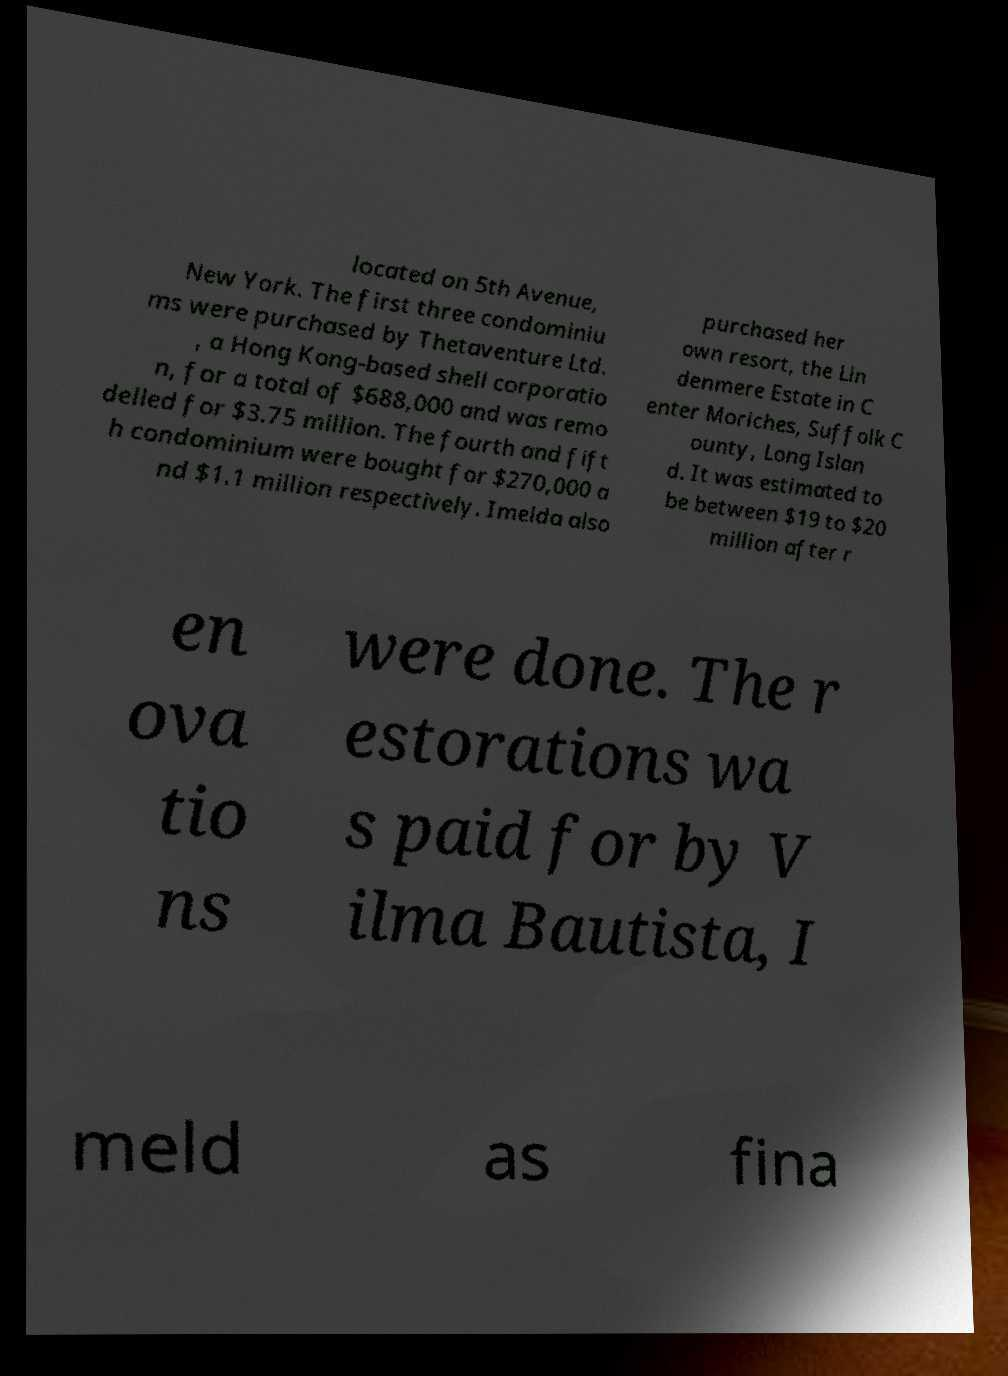For documentation purposes, I need the text within this image transcribed. Could you provide that? located on 5th Avenue, New York. The first three condominiu ms were purchased by Thetaventure Ltd. , a Hong Kong-based shell corporatio n, for a total of $688,000 and was remo delled for $3.75 million. The fourth and fift h condominium were bought for $270,000 a nd $1.1 million respectively. Imelda also purchased her own resort, the Lin denmere Estate in C enter Moriches, Suffolk C ounty, Long Islan d. It was estimated to be between $19 to $20 million after r en ova tio ns were done. The r estorations wa s paid for by V ilma Bautista, I meld as fina 